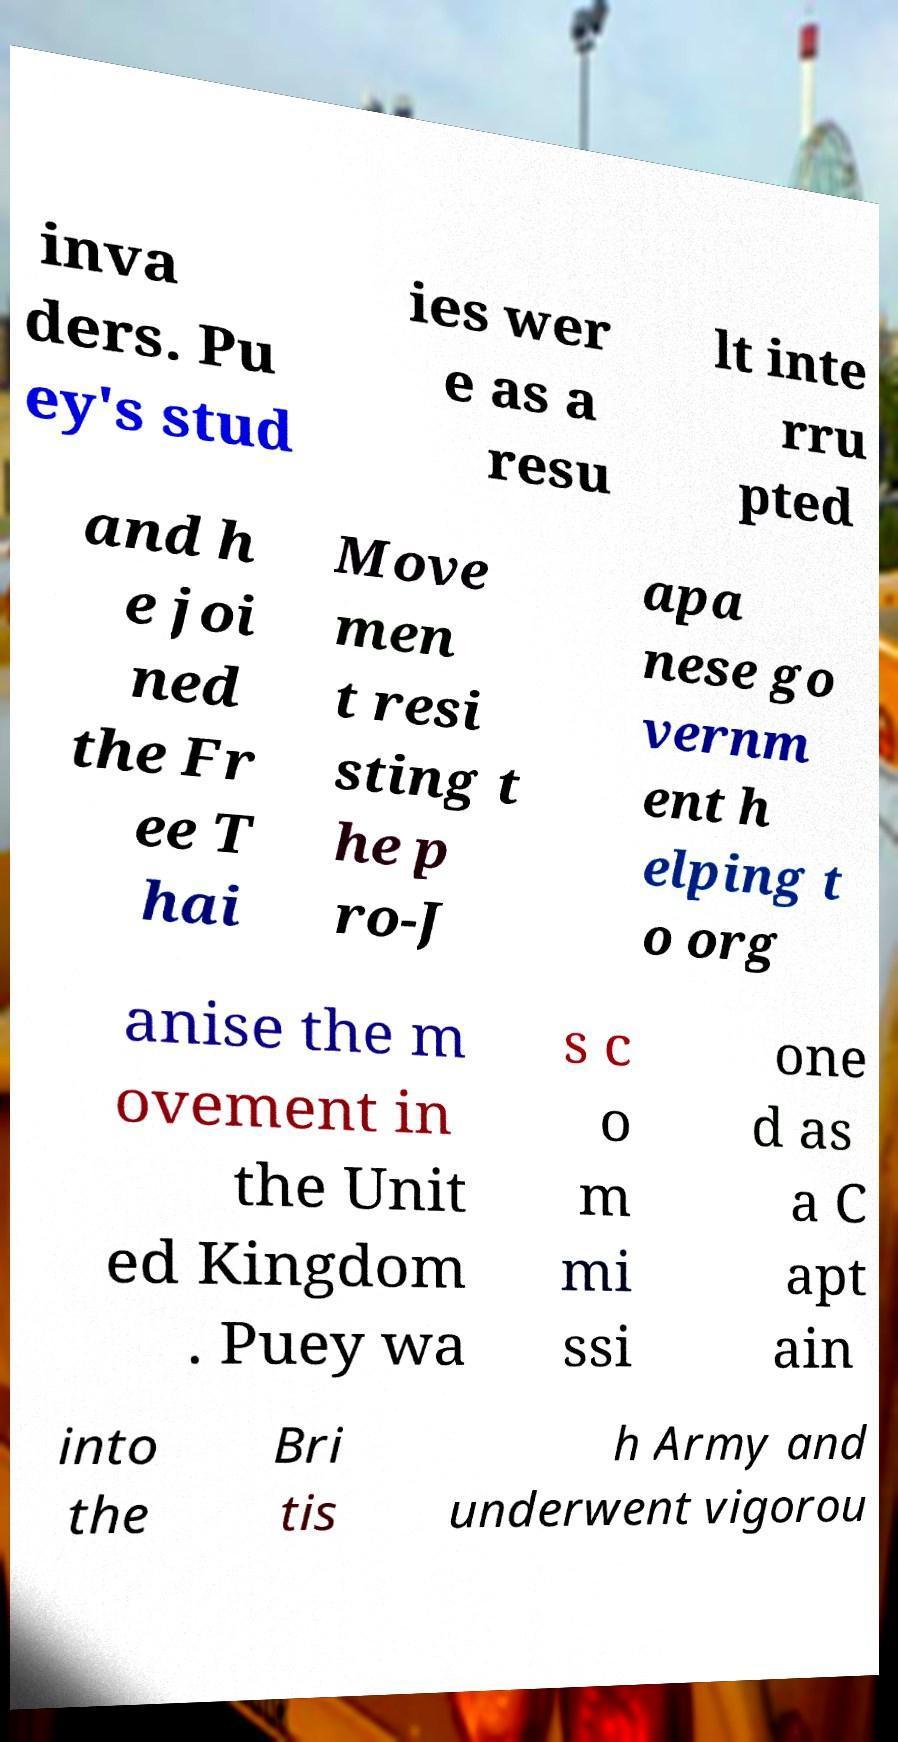There's text embedded in this image that I need extracted. Can you transcribe it verbatim? inva ders. Pu ey's stud ies wer e as a resu lt inte rru pted and h e joi ned the Fr ee T hai Move men t resi sting t he p ro-J apa nese go vernm ent h elping t o org anise the m ovement in the Unit ed Kingdom . Puey wa s c o m mi ssi one d as a C apt ain into the Bri tis h Army and underwent vigorou 